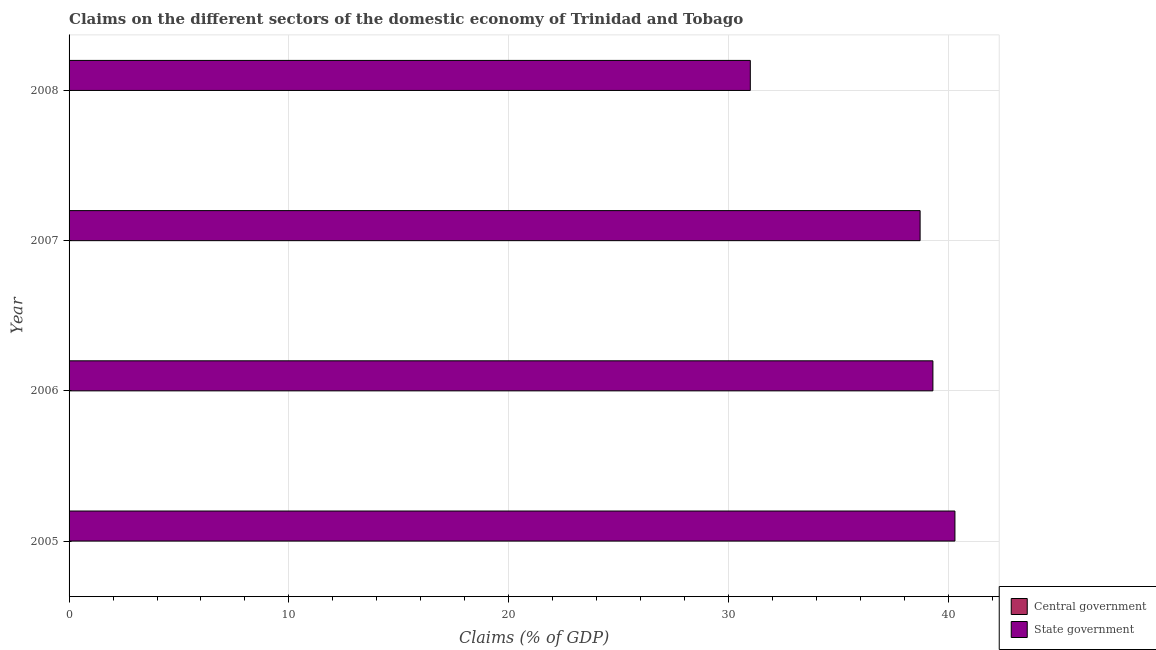How many different coloured bars are there?
Your response must be concise. 1. Are the number of bars per tick equal to the number of legend labels?
Give a very brief answer. No. What is the label of the 4th group of bars from the top?
Ensure brevity in your answer.  2005. In how many cases, is the number of bars for a given year not equal to the number of legend labels?
Keep it short and to the point. 4. Across all years, what is the maximum claims on state government?
Provide a succinct answer. 40.29. Across all years, what is the minimum claims on central government?
Ensure brevity in your answer.  0. What is the total claims on central government in the graph?
Give a very brief answer. 0. What is the difference between the claims on state government in 2007 and that in 2008?
Keep it short and to the point. 7.72. What is the difference between the claims on central government in 2007 and the claims on state government in 2006?
Keep it short and to the point. -39.29. What is the average claims on state government per year?
Make the answer very short. 37.32. In how many years, is the claims on state government greater than 38 %?
Give a very brief answer. 3. Is the claims on state government in 2007 less than that in 2008?
Make the answer very short. No. What is the difference between the highest and the lowest claims on state government?
Offer a very short reply. 9.31. Is the sum of the claims on state government in 2006 and 2007 greater than the maximum claims on central government across all years?
Provide a short and direct response. Yes. Are all the bars in the graph horizontal?
Give a very brief answer. Yes. How many years are there in the graph?
Offer a terse response. 4. What is the difference between two consecutive major ticks on the X-axis?
Offer a very short reply. 10. Are the values on the major ticks of X-axis written in scientific E-notation?
Provide a succinct answer. No. How many legend labels are there?
Provide a succinct answer. 2. What is the title of the graph?
Make the answer very short. Claims on the different sectors of the domestic economy of Trinidad and Tobago. Does "Register a property" appear as one of the legend labels in the graph?
Make the answer very short. No. What is the label or title of the X-axis?
Make the answer very short. Claims (% of GDP). What is the Claims (% of GDP) of Central government in 2005?
Your answer should be very brief. 0. What is the Claims (% of GDP) of State government in 2005?
Provide a succinct answer. 40.29. What is the Claims (% of GDP) in State government in 2006?
Ensure brevity in your answer.  39.29. What is the Claims (% of GDP) of State government in 2007?
Your answer should be very brief. 38.71. What is the Claims (% of GDP) of State government in 2008?
Offer a very short reply. 30.99. Across all years, what is the maximum Claims (% of GDP) in State government?
Offer a very short reply. 40.29. Across all years, what is the minimum Claims (% of GDP) in State government?
Your response must be concise. 30.99. What is the total Claims (% of GDP) in Central government in the graph?
Your answer should be very brief. 0. What is the total Claims (% of GDP) in State government in the graph?
Offer a terse response. 149.29. What is the difference between the Claims (% of GDP) in State government in 2005 and that in 2006?
Give a very brief answer. 1. What is the difference between the Claims (% of GDP) of State government in 2005 and that in 2007?
Your answer should be very brief. 1.58. What is the difference between the Claims (% of GDP) in State government in 2005 and that in 2008?
Provide a short and direct response. 9.31. What is the difference between the Claims (% of GDP) of State government in 2006 and that in 2007?
Your answer should be very brief. 0.58. What is the difference between the Claims (% of GDP) in State government in 2006 and that in 2008?
Make the answer very short. 8.31. What is the difference between the Claims (% of GDP) in State government in 2007 and that in 2008?
Provide a short and direct response. 7.72. What is the average Claims (% of GDP) in Central government per year?
Offer a very short reply. 0. What is the average Claims (% of GDP) of State government per year?
Offer a very short reply. 37.32. What is the ratio of the Claims (% of GDP) of State government in 2005 to that in 2006?
Ensure brevity in your answer.  1.03. What is the ratio of the Claims (% of GDP) in State government in 2005 to that in 2007?
Your response must be concise. 1.04. What is the ratio of the Claims (% of GDP) of State government in 2005 to that in 2008?
Keep it short and to the point. 1.3. What is the ratio of the Claims (% of GDP) of State government in 2006 to that in 2007?
Provide a short and direct response. 1.01. What is the ratio of the Claims (% of GDP) of State government in 2006 to that in 2008?
Ensure brevity in your answer.  1.27. What is the ratio of the Claims (% of GDP) in State government in 2007 to that in 2008?
Provide a short and direct response. 1.25. What is the difference between the highest and the second highest Claims (% of GDP) of State government?
Give a very brief answer. 1. What is the difference between the highest and the lowest Claims (% of GDP) of State government?
Keep it short and to the point. 9.31. 